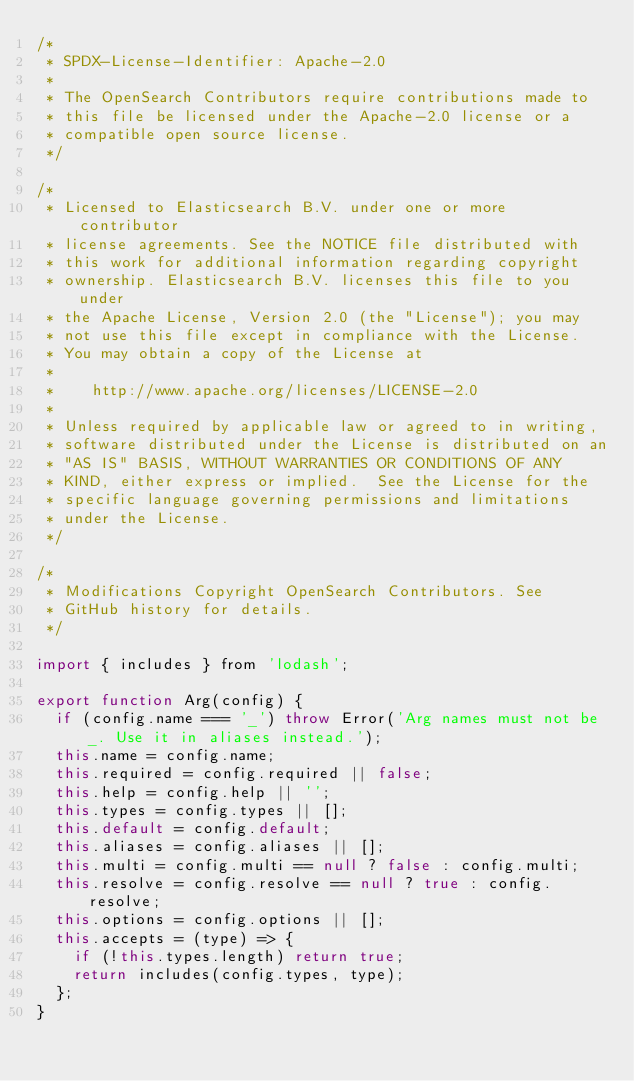Convert code to text. <code><loc_0><loc_0><loc_500><loc_500><_JavaScript_>/*
 * SPDX-License-Identifier: Apache-2.0
 *
 * The OpenSearch Contributors require contributions made to
 * this file be licensed under the Apache-2.0 license or a
 * compatible open source license.
 */

/*
 * Licensed to Elasticsearch B.V. under one or more contributor
 * license agreements. See the NOTICE file distributed with
 * this work for additional information regarding copyright
 * ownership. Elasticsearch B.V. licenses this file to you under
 * the Apache License, Version 2.0 (the "License"); you may
 * not use this file except in compliance with the License.
 * You may obtain a copy of the License at
 *
 *    http://www.apache.org/licenses/LICENSE-2.0
 *
 * Unless required by applicable law or agreed to in writing,
 * software distributed under the License is distributed on an
 * "AS IS" BASIS, WITHOUT WARRANTIES OR CONDITIONS OF ANY
 * KIND, either express or implied.  See the License for the
 * specific language governing permissions and limitations
 * under the License.
 */

/*
 * Modifications Copyright OpenSearch Contributors. See
 * GitHub history for details.
 */

import { includes } from 'lodash';

export function Arg(config) {
  if (config.name === '_') throw Error('Arg names must not be _. Use it in aliases instead.');
  this.name = config.name;
  this.required = config.required || false;
  this.help = config.help || '';
  this.types = config.types || [];
  this.default = config.default;
  this.aliases = config.aliases || [];
  this.multi = config.multi == null ? false : config.multi;
  this.resolve = config.resolve == null ? true : config.resolve;
  this.options = config.options || [];
  this.accepts = (type) => {
    if (!this.types.length) return true;
    return includes(config.types, type);
  };
}
</code> 